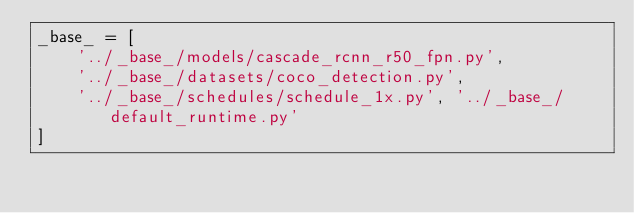Convert code to text. <code><loc_0><loc_0><loc_500><loc_500><_Python_>_base_ = [
    '../_base_/models/cascade_rcnn_r50_fpn.py',
    '../_base_/datasets/coco_detection.py',
    '../_base_/schedules/schedule_1x.py', '../_base_/default_runtime.py'
]
</code> 